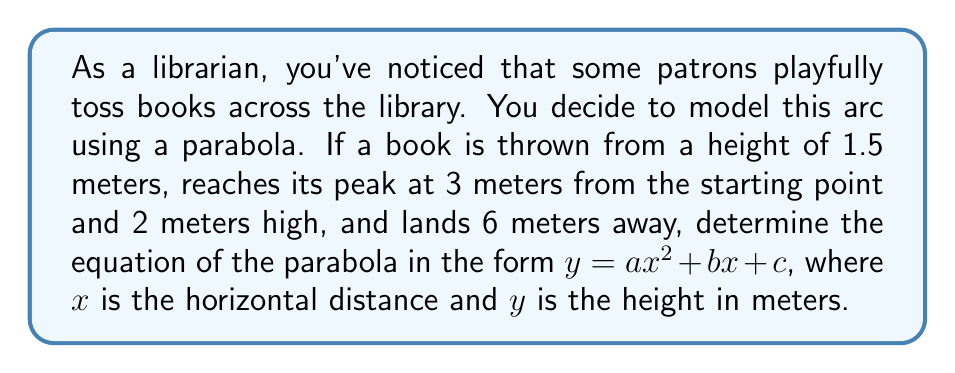Could you help me with this problem? Let's approach this step-by-step:

1) The general form of a parabola is $y = ax^2 + bx + c$, where $a$, $b$, and $c$ are constants we need to determine.

2) We have three points on this parabola:
   - Starting point: (0, 1.5)
   - Peak point: (3, 2)
   - Landing point: (6, 0)

3) Let's use these points to create a system of equations:

   $1.5 = a(0)^2 + b(0) + c$
   $2 = a(3)^2 + b(3) + c$
   $0 = a(6)^2 + b(6) + c$

4) From the first equation:
   $c = 1.5$

5) Substituting this into the other two equations:

   $2 = 9a + 3b + 1.5$
   $0 = 36a + 6b + 1.5$

6) Simplify:
   $0.5 = 9a + 3b$
   $-1.5 = 36a + 6b$

7) Multiply the first equation by 4 and the second by -1:
   $2 = 36a + 12b$
   $1.5 = -36a - 6b$

8) Add these equations:
   $3.5 = 6b$
   $b = \frac{7}{12}$

9) Substitute this back into $0.5 = 9a + 3b$:
   $0.5 = 9a + 3(\frac{7}{12})$
   $0.5 = 9a + \frac{7}{4}$
   $-\frac{5}{4} = 9a$
   $a = -\frac{5}{36}$

10) Therefore, the equation of the parabola is:
    $y = -\frac{5}{36}x^2 + \frac{7}{12}x + 1.5$
Answer: $y = -\frac{5}{36}x^2 + \frac{7}{12}x + 1.5$ 